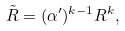<formula> <loc_0><loc_0><loc_500><loc_500>\tilde { R } = ( \alpha ^ { \prime } ) ^ { k - 1 } R ^ { k } ,</formula> 